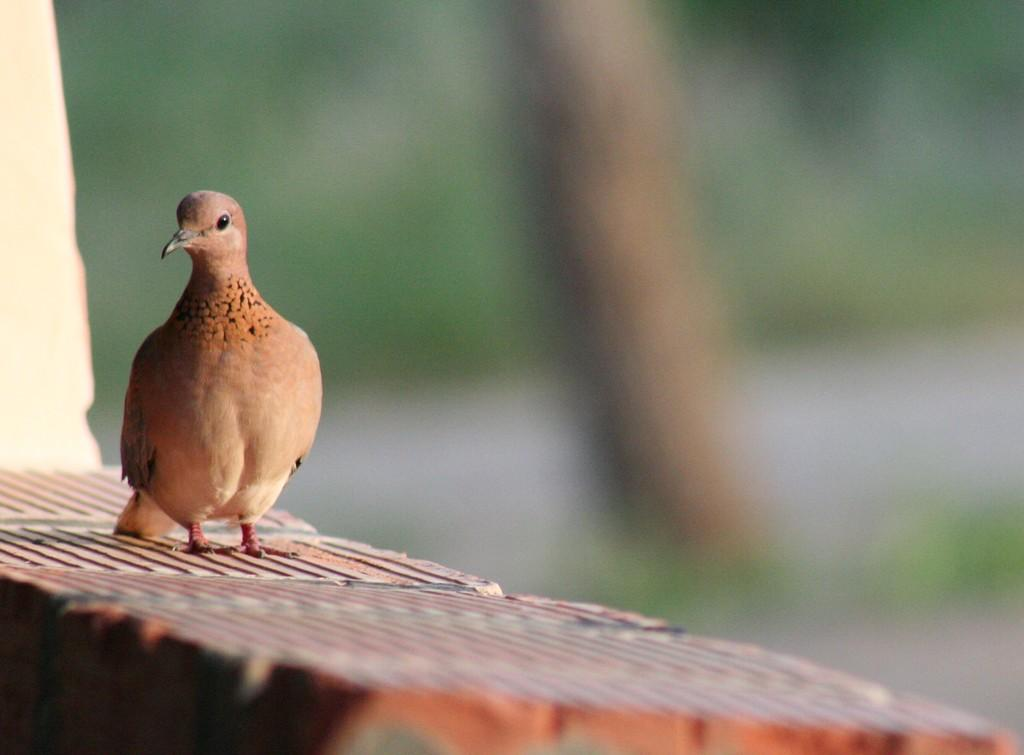What is on the wall in the image? There is a bird on the wall in the image. Can you describe the background of the image? The background of the image is blurred. What type of record is the bird holding in the image? There is no record present in the image, as it features a bird on the wall with a blurred background. 